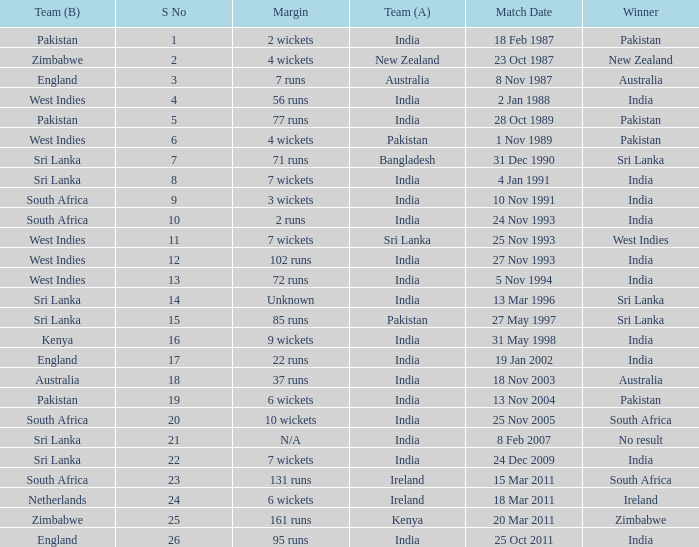Could you parse the entire table? {'header': ['Team (B)', 'S No', 'Margin', 'Team (A)', 'Match Date', 'Winner'], 'rows': [['Pakistan', '1', '2 wickets', 'India', '18 Feb 1987', 'Pakistan'], ['Zimbabwe', '2', '4 wickets', 'New Zealand', '23 Oct 1987', 'New Zealand'], ['England', '3', '7 runs', 'Australia', '8 Nov 1987', 'Australia'], ['West Indies', '4', '56 runs', 'India', '2 Jan 1988', 'India'], ['Pakistan', '5', '77 runs', 'India', '28 Oct 1989', 'Pakistan'], ['West Indies', '6', '4 wickets', 'Pakistan', '1 Nov 1989', 'Pakistan'], ['Sri Lanka', '7', '71 runs', 'Bangladesh', '31 Dec 1990', 'Sri Lanka'], ['Sri Lanka', '8', '7 wickets', 'India', '4 Jan 1991', 'India'], ['South Africa', '9', '3 wickets', 'India', '10 Nov 1991', 'India'], ['South Africa', '10', '2 runs', 'India', '24 Nov 1993', 'India'], ['West Indies', '11', '7 wickets', 'Sri Lanka', '25 Nov 1993', 'West Indies'], ['West Indies', '12', '102 runs', 'India', '27 Nov 1993', 'India'], ['West Indies', '13', '72 runs', 'India', '5 Nov 1994', 'India'], ['Sri Lanka', '14', 'Unknown', 'India', '13 Mar 1996', 'Sri Lanka'], ['Sri Lanka', '15', '85 runs', 'Pakistan', '27 May 1997', 'Sri Lanka'], ['Kenya', '16', '9 wickets', 'India', '31 May 1998', 'India'], ['England', '17', '22 runs', 'India', '19 Jan 2002', 'India'], ['Australia', '18', '37 runs', 'India', '18 Nov 2003', 'Australia'], ['Pakistan', '19', '6 wickets', 'India', '13 Nov 2004', 'Pakistan'], ['South Africa', '20', '10 wickets', 'India', '25 Nov 2005', 'South Africa'], ['Sri Lanka', '21', 'N/A', 'India', '8 Feb 2007', 'No result'], ['Sri Lanka', '22', '7 wickets', 'India', '24 Dec 2009', 'India'], ['South Africa', '23', '131 runs', 'Ireland', '15 Mar 2011', 'South Africa'], ['Netherlands', '24', '6 wickets', 'Ireland', '18 Mar 2011', 'Ireland'], ['Zimbabwe', '25', '161 runs', 'Kenya', '20 Mar 2011', 'Zimbabwe'], ['England', '26', '95 runs', 'India', '25 Oct 2011', 'India']]} What date did the West Indies win the match? 25 Nov 1993. 